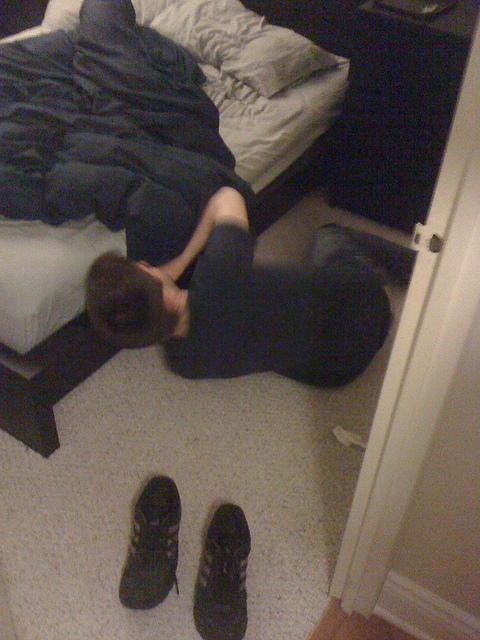Where are the shoes?
Answer briefly. On floor. Is the man sleeping on the floor?
Concise answer only. Yes. Is the guy looking for something?
Give a very brief answer. Yes. 